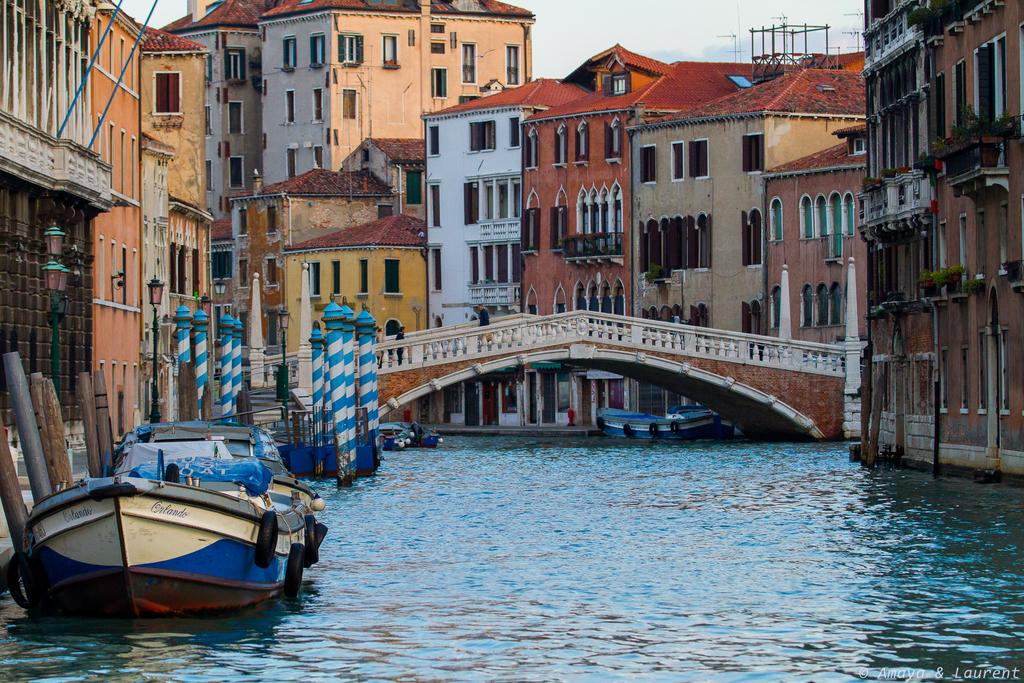What can be seen in the sky in the image? Sky is visible in the image. What type of structures are present in the image? There are buildings in the image. What architectural feature is present in the image? There is a bridge in the image. What type of vehicles are present in the image? There are boats in the image. What natural element is visible in the image? There is water visible in the image. What shape is the talking care in the image? There is no talking care present in the image. What type of care is being provided to the boats in the image? The image does not show any care being provided to the boats; they are simply floating on the water. 